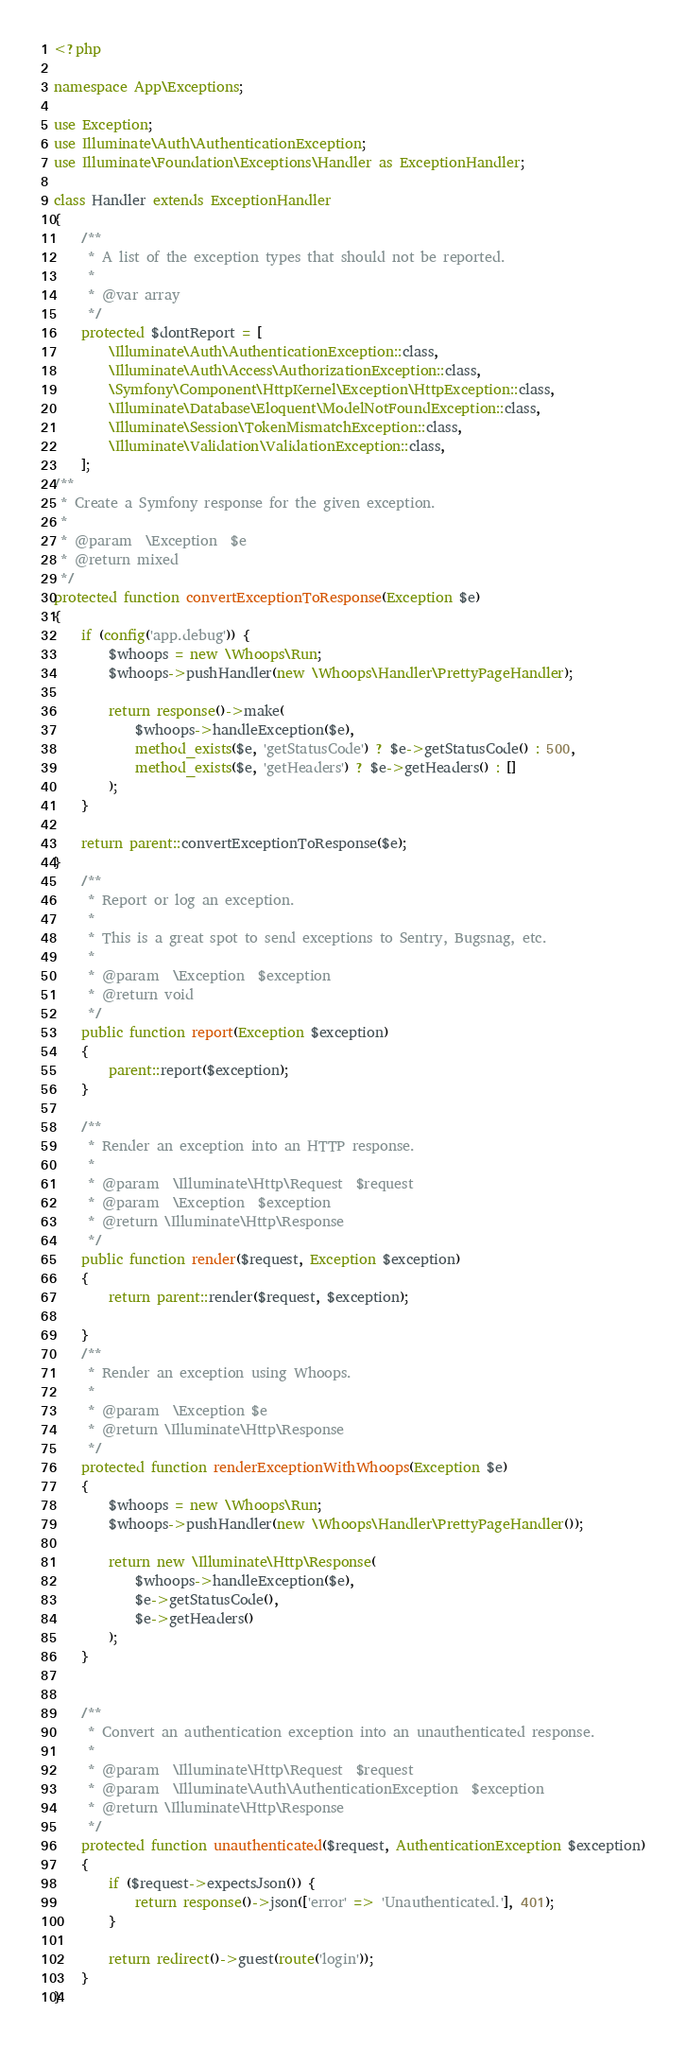<code> <loc_0><loc_0><loc_500><loc_500><_PHP_><?php

namespace App\Exceptions;

use Exception;
use Illuminate\Auth\AuthenticationException;
use Illuminate\Foundation\Exceptions\Handler as ExceptionHandler;

class Handler extends ExceptionHandler
{
    /**
     * A list of the exception types that should not be reported.
     *
     * @var array
     */
    protected $dontReport = [
        \Illuminate\Auth\AuthenticationException::class,
        \Illuminate\Auth\Access\AuthorizationException::class,
        \Symfony\Component\HttpKernel\Exception\HttpException::class,
        \Illuminate\Database\Eloquent\ModelNotFoundException::class,
        \Illuminate\Session\TokenMismatchException::class,
        \Illuminate\Validation\ValidationException::class,
    ];
/**
 * Create a Symfony response for the given exception.
 *
 * @param  \Exception  $e
 * @return mixed
 */
protected function convertExceptionToResponse(Exception $e)
{
    if (config('app.debug')) {
        $whoops = new \Whoops\Run;
        $whoops->pushHandler(new \Whoops\Handler\PrettyPageHandler);

        return response()->make(
            $whoops->handleException($e),
            method_exists($e, 'getStatusCode') ? $e->getStatusCode() : 500,
            method_exists($e, 'getHeaders') ? $e->getHeaders() : []
        );
    }

    return parent::convertExceptionToResponse($e);
} 
    /**
     * Report or log an exception.
     *
     * This is a great spot to send exceptions to Sentry, Bugsnag, etc.
     *
     * @param  \Exception  $exception
     * @return void
     */
    public function report(Exception $exception)
    {
        parent::report($exception);
    }

    /**
     * Render an exception into an HTTP response.
     *
     * @param  \Illuminate\Http\Request  $request
     * @param  \Exception  $exception
     * @return \Illuminate\Http\Response
     */
    public function render($request, Exception $exception)
    {
        return parent::render($request, $exception);

    }
    /**
     * Render an exception using Whoops.
     * 
     * @param  \Exception $e
     * @return \Illuminate\Http\Response
     */
    protected function renderExceptionWithWhoops(Exception $e)
    {
        $whoops = new \Whoops\Run;
        $whoops->pushHandler(new \Whoops\Handler\PrettyPageHandler());
 
        return new \Illuminate\Http\Response(
            $whoops->handleException($e),
            $e->getStatusCode(),
            $e->getHeaders()
        );
    }

 
    /**
     * Convert an authentication exception into an unauthenticated response.
     *
     * @param  \Illuminate\Http\Request  $request
     * @param  \Illuminate\Auth\AuthenticationException  $exception
     * @return \Illuminate\Http\Response
     */
    protected function unauthenticated($request, AuthenticationException $exception)
    {
        if ($request->expectsJson()) {
            return response()->json(['error' => 'Unauthenticated.'], 401);
        }

        return redirect()->guest(route('login'));
    }
}
</code> 